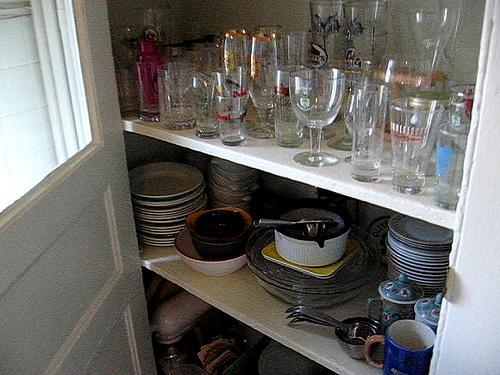Where are these items being stored? pantry 